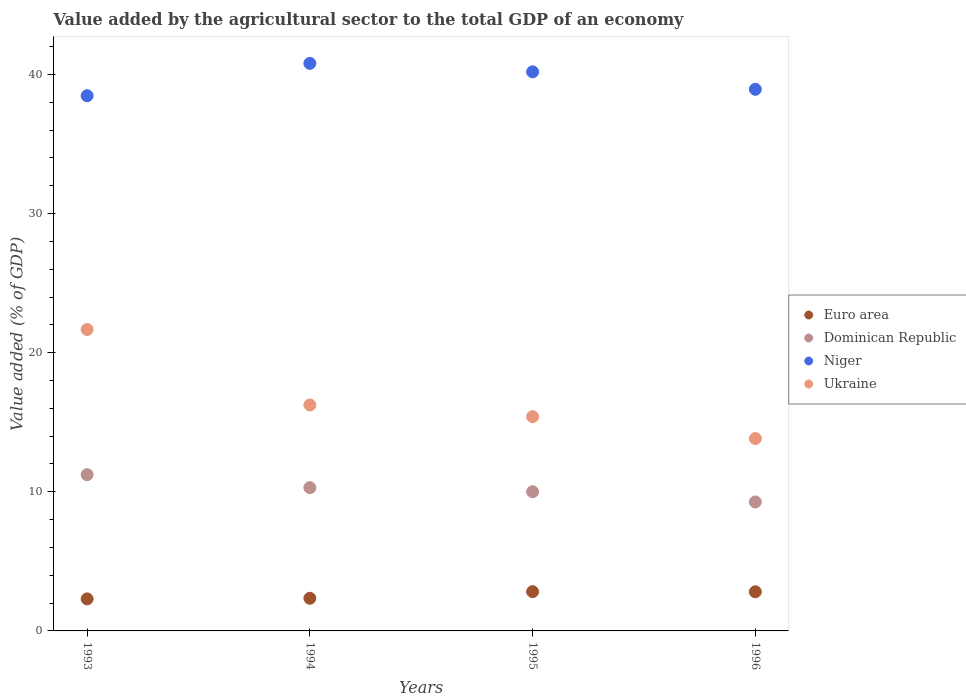How many different coloured dotlines are there?
Provide a short and direct response. 4. What is the value added by the agricultural sector to the total GDP in Dominican Republic in 1993?
Ensure brevity in your answer.  11.23. Across all years, what is the maximum value added by the agricultural sector to the total GDP in Euro area?
Provide a succinct answer. 2.82. Across all years, what is the minimum value added by the agricultural sector to the total GDP in Dominican Republic?
Keep it short and to the point. 9.27. In which year was the value added by the agricultural sector to the total GDP in Euro area minimum?
Offer a terse response. 1993. What is the total value added by the agricultural sector to the total GDP in Euro area in the graph?
Your answer should be compact. 10.29. What is the difference between the value added by the agricultural sector to the total GDP in Euro area in 1995 and that in 1996?
Make the answer very short. 0.01. What is the difference between the value added by the agricultural sector to the total GDP in Euro area in 1993 and the value added by the agricultural sector to the total GDP in Ukraine in 1994?
Provide a succinct answer. -13.94. What is the average value added by the agricultural sector to the total GDP in Euro area per year?
Offer a terse response. 2.57. In the year 1995, what is the difference between the value added by the agricultural sector to the total GDP in Dominican Republic and value added by the agricultural sector to the total GDP in Niger?
Provide a short and direct response. -30.18. What is the ratio of the value added by the agricultural sector to the total GDP in Niger in 1993 to that in 1996?
Your response must be concise. 0.99. Is the value added by the agricultural sector to the total GDP in Euro area in 1995 less than that in 1996?
Make the answer very short. No. Is the difference between the value added by the agricultural sector to the total GDP in Dominican Republic in 1993 and 1996 greater than the difference between the value added by the agricultural sector to the total GDP in Niger in 1993 and 1996?
Make the answer very short. Yes. What is the difference between the highest and the second highest value added by the agricultural sector to the total GDP in Niger?
Make the answer very short. 0.61. What is the difference between the highest and the lowest value added by the agricultural sector to the total GDP in Euro area?
Provide a short and direct response. 0.52. Is the sum of the value added by the agricultural sector to the total GDP in Niger in 1994 and 1996 greater than the maximum value added by the agricultural sector to the total GDP in Euro area across all years?
Your answer should be compact. Yes. Is it the case that in every year, the sum of the value added by the agricultural sector to the total GDP in Ukraine and value added by the agricultural sector to the total GDP in Dominican Republic  is greater than the value added by the agricultural sector to the total GDP in Niger?
Make the answer very short. No. Does the value added by the agricultural sector to the total GDP in Niger monotonically increase over the years?
Keep it short and to the point. No. Is the value added by the agricultural sector to the total GDP in Euro area strictly less than the value added by the agricultural sector to the total GDP in Dominican Republic over the years?
Offer a terse response. Yes. Are the values on the major ticks of Y-axis written in scientific E-notation?
Provide a short and direct response. No. Does the graph contain grids?
Keep it short and to the point. No. What is the title of the graph?
Give a very brief answer. Value added by the agricultural sector to the total GDP of an economy. Does "Chile" appear as one of the legend labels in the graph?
Your answer should be very brief. No. What is the label or title of the Y-axis?
Give a very brief answer. Value added (% of GDP). What is the Value added (% of GDP) of Euro area in 1993?
Your answer should be very brief. 2.3. What is the Value added (% of GDP) in Dominican Republic in 1993?
Your response must be concise. 11.23. What is the Value added (% of GDP) in Niger in 1993?
Provide a succinct answer. 38.47. What is the Value added (% of GDP) in Ukraine in 1993?
Your response must be concise. 21.67. What is the Value added (% of GDP) of Euro area in 1994?
Make the answer very short. 2.35. What is the Value added (% of GDP) of Dominican Republic in 1994?
Provide a succinct answer. 10.3. What is the Value added (% of GDP) in Niger in 1994?
Give a very brief answer. 40.8. What is the Value added (% of GDP) in Ukraine in 1994?
Your answer should be compact. 16.24. What is the Value added (% of GDP) in Euro area in 1995?
Provide a short and direct response. 2.82. What is the Value added (% of GDP) in Dominican Republic in 1995?
Your response must be concise. 10.01. What is the Value added (% of GDP) of Niger in 1995?
Provide a succinct answer. 40.19. What is the Value added (% of GDP) in Ukraine in 1995?
Give a very brief answer. 15.4. What is the Value added (% of GDP) in Euro area in 1996?
Offer a very short reply. 2.81. What is the Value added (% of GDP) in Dominican Republic in 1996?
Ensure brevity in your answer.  9.27. What is the Value added (% of GDP) in Niger in 1996?
Provide a succinct answer. 38.93. What is the Value added (% of GDP) in Ukraine in 1996?
Offer a very short reply. 13.83. Across all years, what is the maximum Value added (% of GDP) in Euro area?
Your answer should be very brief. 2.82. Across all years, what is the maximum Value added (% of GDP) of Dominican Republic?
Your answer should be very brief. 11.23. Across all years, what is the maximum Value added (% of GDP) in Niger?
Make the answer very short. 40.8. Across all years, what is the maximum Value added (% of GDP) of Ukraine?
Your answer should be compact. 21.67. Across all years, what is the minimum Value added (% of GDP) of Euro area?
Give a very brief answer. 2.3. Across all years, what is the minimum Value added (% of GDP) in Dominican Republic?
Your answer should be very brief. 9.27. Across all years, what is the minimum Value added (% of GDP) of Niger?
Make the answer very short. 38.47. Across all years, what is the minimum Value added (% of GDP) in Ukraine?
Give a very brief answer. 13.83. What is the total Value added (% of GDP) in Euro area in the graph?
Offer a very short reply. 10.29. What is the total Value added (% of GDP) of Dominican Republic in the graph?
Offer a terse response. 40.81. What is the total Value added (% of GDP) of Niger in the graph?
Your response must be concise. 158.4. What is the total Value added (% of GDP) of Ukraine in the graph?
Give a very brief answer. 67.14. What is the difference between the Value added (% of GDP) of Euro area in 1993 and that in 1994?
Provide a succinct answer. -0.05. What is the difference between the Value added (% of GDP) of Dominican Republic in 1993 and that in 1994?
Provide a short and direct response. 0.93. What is the difference between the Value added (% of GDP) in Niger in 1993 and that in 1994?
Your response must be concise. -2.33. What is the difference between the Value added (% of GDP) in Ukraine in 1993 and that in 1994?
Provide a short and direct response. 5.43. What is the difference between the Value added (% of GDP) of Euro area in 1993 and that in 1995?
Offer a very short reply. -0.52. What is the difference between the Value added (% of GDP) in Dominican Republic in 1993 and that in 1995?
Keep it short and to the point. 1.23. What is the difference between the Value added (% of GDP) of Niger in 1993 and that in 1995?
Keep it short and to the point. -1.72. What is the difference between the Value added (% of GDP) of Ukraine in 1993 and that in 1995?
Keep it short and to the point. 6.27. What is the difference between the Value added (% of GDP) of Euro area in 1993 and that in 1996?
Your answer should be compact. -0.51. What is the difference between the Value added (% of GDP) in Dominican Republic in 1993 and that in 1996?
Ensure brevity in your answer.  1.96. What is the difference between the Value added (% of GDP) of Niger in 1993 and that in 1996?
Your answer should be very brief. -0.46. What is the difference between the Value added (% of GDP) in Ukraine in 1993 and that in 1996?
Your answer should be very brief. 7.84. What is the difference between the Value added (% of GDP) of Euro area in 1994 and that in 1995?
Give a very brief answer. -0.47. What is the difference between the Value added (% of GDP) of Dominican Republic in 1994 and that in 1995?
Your response must be concise. 0.29. What is the difference between the Value added (% of GDP) in Niger in 1994 and that in 1995?
Provide a succinct answer. 0.61. What is the difference between the Value added (% of GDP) in Ukraine in 1994 and that in 1995?
Offer a very short reply. 0.84. What is the difference between the Value added (% of GDP) in Euro area in 1994 and that in 1996?
Give a very brief answer. -0.47. What is the difference between the Value added (% of GDP) of Dominican Republic in 1994 and that in 1996?
Give a very brief answer. 1.03. What is the difference between the Value added (% of GDP) in Niger in 1994 and that in 1996?
Ensure brevity in your answer.  1.87. What is the difference between the Value added (% of GDP) of Ukraine in 1994 and that in 1996?
Provide a short and direct response. 2.41. What is the difference between the Value added (% of GDP) of Euro area in 1995 and that in 1996?
Your answer should be compact. 0.01. What is the difference between the Value added (% of GDP) in Dominican Republic in 1995 and that in 1996?
Ensure brevity in your answer.  0.73. What is the difference between the Value added (% of GDP) of Niger in 1995 and that in 1996?
Give a very brief answer. 1.26. What is the difference between the Value added (% of GDP) in Ukraine in 1995 and that in 1996?
Provide a succinct answer. 1.57. What is the difference between the Value added (% of GDP) of Euro area in 1993 and the Value added (% of GDP) of Dominican Republic in 1994?
Your response must be concise. -8. What is the difference between the Value added (% of GDP) in Euro area in 1993 and the Value added (% of GDP) in Niger in 1994?
Offer a terse response. -38.5. What is the difference between the Value added (% of GDP) of Euro area in 1993 and the Value added (% of GDP) of Ukraine in 1994?
Your answer should be very brief. -13.94. What is the difference between the Value added (% of GDP) in Dominican Republic in 1993 and the Value added (% of GDP) in Niger in 1994?
Provide a succinct answer. -29.57. What is the difference between the Value added (% of GDP) of Dominican Republic in 1993 and the Value added (% of GDP) of Ukraine in 1994?
Your answer should be compact. -5.01. What is the difference between the Value added (% of GDP) of Niger in 1993 and the Value added (% of GDP) of Ukraine in 1994?
Provide a short and direct response. 22.23. What is the difference between the Value added (% of GDP) of Euro area in 1993 and the Value added (% of GDP) of Dominican Republic in 1995?
Your answer should be compact. -7.7. What is the difference between the Value added (% of GDP) in Euro area in 1993 and the Value added (% of GDP) in Niger in 1995?
Offer a terse response. -37.89. What is the difference between the Value added (% of GDP) in Euro area in 1993 and the Value added (% of GDP) in Ukraine in 1995?
Ensure brevity in your answer.  -13.1. What is the difference between the Value added (% of GDP) of Dominican Republic in 1993 and the Value added (% of GDP) of Niger in 1995?
Your answer should be very brief. -28.96. What is the difference between the Value added (% of GDP) of Dominican Republic in 1993 and the Value added (% of GDP) of Ukraine in 1995?
Keep it short and to the point. -4.17. What is the difference between the Value added (% of GDP) of Niger in 1993 and the Value added (% of GDP) of Ukraine in 1995?
Give a very brief answer. 23.07. What is the difference between the Value added (% of GDP) of Euro area in 1993 and the Value added (% of GDP) of Dominican Republic in 1996?
Offer a terse response. -6.97. What is the difference between the Value added (% of GDP) of Euro area in 1993 and the Value added (% of GDP) of Niger in 1996?
Offer a very short reply. -36.63. What is the difference between the Value added (% of GDP) in Euro area in 1993 and the Value added (% of GDP) in Ukraine in 1996?
Your response must be concise. -11.53. What is the difference between the Value added (% of GDP) in Dominican Republic in 1993 and the Value added (% of GDP) in Niger in 1996?
Provide a succinct answer. -27.7. What is the difference between the Value added (% of GDP) in Dominican Republic in 1993 and the Value added (% of GDP) in Ukraine in 1996?
Your response must be concise. -2.6. What is the difference between the Value added (% of GDP) in Niger in 1993 and the Value added (% of GDP) in Ukraine in 1996?
Provide a succinct answer. 24.64. What is the difference between the Value added (% of GDP) of Euro area in 1994 and the Value added (% of GDP) of Dominican Republic in 1995?
Offer a terse response. -7.66. What is the difference between the Value added (% of GDP) of Euro area in 1994 and the Value added (% of GDP) of Niger in 1995?
Your answer should be compact. -37.84. What is the difference between the Value added (% of GDP) in Euro area in 1994 and the Value added (% of GDP) in Ukraine in 1995?
Offer a very short reply. -13.05. What is the difference between the Value added (% of GDP) of Dominican Republic in 1994 and the Value added (% of GDP) of Niger in 1995?
Give a very brief answer. -29.89. What is the difference between the Value added (% of GDP) of Dominican Republic in 1994 and the Value added (% of GDP) of Ukraine in 1995?
Provide a succinct answer. -5.1. What is the difference between the Value added (% of GDP) of Niger in 1994 and the Value added (% of GDP) of Ukraine in 1995?
Make the answer very short. 25.4. What is the difference between the Value added (% of GDP) in Euro area in 1994 and the Value added (% of GDP) in Dominican Republic in 1996?
Your answer should be compact. -6.92. What is the difference between the Value added (% of GDP) in Euro area in 1994 and the Value added (% of GDP) in Niger in 1996?
Provide a succinct answer. -36.59. What is the difference between the Value added (% of GDP) in Euro area in 1994 and the Value added (% of GDP) in Ukraine in 1996?
Provide a short and direct response. -11.48. What is the difference between the Value added (% of GDP) of Dominican Republic in 1994 and the Value added (% of GDP) of Niger in 1996?
Give a very brief answer. -28.64. What is the difference between the Value added (% of GDP) of Dominican Republic in 1994 and the Value added (% of GDP) of Ukraine in 1996?
Provide a short and direct response. -3.53. What is the difference between the Value added (% of GDP) in Niger in 1994 and the Value added (% of GDP) in Ukraine in 1996?
Ensure brevity in your answer.  26.97. What is the difference between the Value added (% of GDP) in Euro area in 1995 and the Value added (% of GDP) in Dominican Republic in 1996?
Make the answer very short. -6.45. What is the difference between the Value added (% of GDP) in Euro area in 1995 and the Value added (% of GDP) in Niger in 1996?
Provide a succinct answer. -36.11. What is the difference between the Value added (% of GDP) of Euro area in 1995 and the Value added (% of GDP) of Ukraine in 1996?
Provide a succinct answer. -11.01. What is the difference between the Value added (% of GDP) of Dominican Republic in 1995 and the Value added (% of GDP) of Niger in 1996?
Your response must be concise. -28.93. What is the difference between the Value added (% of GDP) in Dominican Republic in 1995 and the Value added (% of GDP) in Ukraine in 1996?
Offer a very short reply. -3.82. What is the difference between the Value added (% of GDP) in Niger in 1995 and the Value added (% of GDP) in Ukraine in 1996?
Your answer should be compact. 26.36. What is the average Value added (% of GDP) in Euro area per year?
Provide a succinct answer. 2.57. What is the average Value added (% of GDP) in Dominican Republic per year?
Your answer should be compact. 10.2. What is the average Value added (% of GDP) in Niger per year?
Provide a succinct answer. 39.6. What is the average Value added (% of GDP) of Ukraine per year?
Offer a very short reply. 16.79. In the year 1993, what is the difference between the Value added (% of GDP) of Euro area and Value added (% of GDP) of Dominican Republic?
Provide a short and direct response. -8.93. In the year 1993, what is the difference between the Value added (% of GDP) in Euro area and Value added (% of GDP) in Niger?
Offer a terse response. -36.17. In the year 1993, what is the difference between the Value added (% of GDP) of Euro area and Value added (% of GDP) of Ukraine?
Your answer should be very brief. -19.37. In the year 1993, what is the difference between the Value added (% of GDP) in Dominican Republic and Value added (% of GDP) in Niger?
Ensure brevity in your answer.  -27.24. In the year 1993, what is the difference between the Value added (% of GDP) of Dominican Republic and Value added (% of GDP) of Ukraine?
Your response must be concise. -10.44. In the year 1993, what is the difference between the Value added (% of GDP) of Niger and Value added (% of GDP) of Ukraine?
Offer a terse response. 16.8. In the year 1994, what is the difference between the Value added (% of GDP) of Euro area and Value added (% of GDP) of Dominican Republic?
Your answer should be very brief. -7.95. In the year 1994, what is the difference between the Value added (% of GDP) of Euro area and Value added (% of GDP) of Niger?
Give a very brief answer. -38.45. In the year 1994, what is the difference between the Value added (% of GDP) in Euro area and Value added (% of GDP) in Ukraine?
Your answer should be compact. -13.9. In the year 1994, what is the difference between the Value added (% of GDP) of Dominican Republic and Value added (% of GDP) of Niger?
Your answer should be very brief. -30.5. In the year 1994, what is the difference between the Value added (% of GDP) in Dominican Republic and Value added (% of GDP) in Ukraine?
Ensure brevity in your answer.  -5.95. In the year 1994, what is the difference between the Value added (% of GDP) of Niger and Value added (% of GDP) of Ukraine?
Give a very brief answer. 24.56. In the year 1995, what is the difference between the Value added (% of GDP) in Euro area and Value added (% of GDP) in Dominican Republic?
Your answer should be compact. -7.18. In the year 1995, what is the difference between the Value added (% of GDP) in Euro area and Value added (% of GDP) in Niger?
Provide a succinct answer. -37.37. In the year 1995, what is the difference between the Value added (% of GDP) of Euro area and Value added (% of GDP) of Ukraine?
Your answer should be very brief. -12.58. In the year 1995, what is the difference between the Value added (% of GDP) of Dominican Republic and Value added (% of GDP) of Niger?
Offer a terse response. -30.18. In the year 1995, what is the difference between the Value added (% of GDP) in Dominican Republic and Value added (% of GDP) in Ukraine?
Offer a very short reply. -5.39. In the year 1995, what is the difference between the Value added (% of GDP) in Niger and Value added (% of GDP) in Ukraine?
Offer a very short reply. 24.79. In the year 1996, what is the difference between the Value added (% of GDP) in Euro area and Value added (% of GDP) in Dominican Republic?
Keep it short and to the point. -6.46. In the year 1996, what is the difference between the Value added (% of GDP) in Euro area and Value added (% of GDP) in Niger?
Make the answer very short. -36.12. In the year 1996, what is the difference between the Value added (% of GDP) of Euro area and Value added (% of GDP) of Ukraine?
Offer a very short reply. -11.01. In the year 1996, what is the difference between the Value added (% of GDP) of Dominican Republic and Value added (% of GDP) of Niger?
Offer a very short reply. -29.66. In the year 1996, what is the difference between the Value added (% of GDP) in Dominican Republic and Value added (% of GDP) in Ukraine?
Keep it short and to the point. -4.56. In the year 1996, what is the difference between the Value added (% of GDP) in Niger and Value added (% of GDP) in Ukraine?
Provide a short and direct response. 25.11. What is the ratio of the Value added (% of GDP) of Euro area in 1993 to that in 1994?
Keep it short and to the point. 0.98. What is the ratio of the Value added (% of GDP) of Dominican Republic in 1993 to that in 1994?
Your answer should be compact. 1.09. What is the ratio of the Value added (% of GDP) of Niger in 1993 to that in 1994?
Provide a succinct answer. 0.94. What is the ratio of the Value added (% of GDP) in Ukraine in 1993 to that in 1994?
Make the answer very short. 1.33. What is the ratio of the Value added (% of GDP) in Euro area in 1993 to that in 1995?
Make the answer very short. 0.82. What is the ratio of the Value added (% of GDP) in Dominican Republic in 1993 to that in 1995?
Offer a terse response. 1.12. What is the ratio of the Value added (% of GDP) in Niger in 1993 to that in 1995?
Your response must be concise. 0.96. What is the ratio of the Value added (% of GDP) of Ukraine in 1993 to that in 1995?
Offer a terse response. 1.41. What is the ratio of the Value added (% of GDP) of Euro area in 1993 to that in 1996?
Give a very brief answer. 0.82. What is the ratio of the Value added (% of GDP) of Dominican Republic in 1993 to that in 1996?
Your answer should be compact. 1.21. What is the ratio of the Value added (% of GDP) in Ukraine in 1993 to that in 1996?
Your response must be concise. 1.57. What is the ratio of the Value added (% of GDP) of Euro area in 1994 to that in 1995?
Keep it short and to the point. 0.83. What is the ratio of the Value added (% of GDP) in Dominican Republic in 1994 to that in 1995?
Offer a very short reply. 1.03. What is the ratio of the Value added (% of GDP) of Niger in 1994 to that in 1995?
Make the answer very short. 1.02. What is the ratio of the Value added (% of GDP) in Ukraine in 1994 to that in 1995?
Your answer should be very brief. 1.05. What is the ratio of the Value added (% of GDP) of Euro area in 1994 to that in 1996?
Your answer should be very brief. 0.83. What is the ratio of the Value added (% of GDP) in Dominican Republic in 1994 to that in 1996?
Your response must be concise. 1.11. What is the ratio of the Value added (% of GDP) of Niger in 1994 to that in 1996?
Your answer should be compact. 1.05. What is the ratio of the Value added (% of GDP) in Ukraine in 1994 to that in 1996?
Ensure brevity in your answer.  1.17. What is the ratio of the Value added (% of GDP) in Euro area in 1995 to that in 1996?
Give a very brief answer. 1. What is the ratio of the Value added (% of GDP) of Dominican Republic in 1995 to that in 1996?
Your answer should be compact. 1.08. What is the ratio of the Value added (% of GDP) of Niger in 1995 to that in 1996?
Your answer should be very brief. 1.03. What is the ratio of the Value added (% of GDP) in Ukraine in 1995 to that in 1996?
Offer a terse response. 1.11. What is the difference between the highest and the second highest Value added (% of GDP) of Euro area?
Your answer should be very brief. 0.01. What is the difference between the highest and the second highest Value added (% of GDP) in Dominican Republic?
Make the answer very short. 0.93. What is the difference between the highest and the second highest Value added (% of GDP) in Niger?
Provide a succinct answer. 0.61. What is the difference between the highest and the second highest Value added (% of GDP) of Ukraine?
Provide a short and direct response. 5.43. What is the difference between the highest and the lowest Value added (% of GDP) of Euro area?
Ensure brevity in your answer.  0.52. What is the difference between the highest and the lowest Value added (% of GDP) in Dominican Republic?
Your response must be concise. 1.96. What is the difference between the highest and the lowest Value added (% of GDP) in Niger?
Ensure brevity in your answer.  2.33. What is the difference between the highest and the lowest Value added (% of GDP) of Ukraine?
Provide a succinct answer. 7.84. 